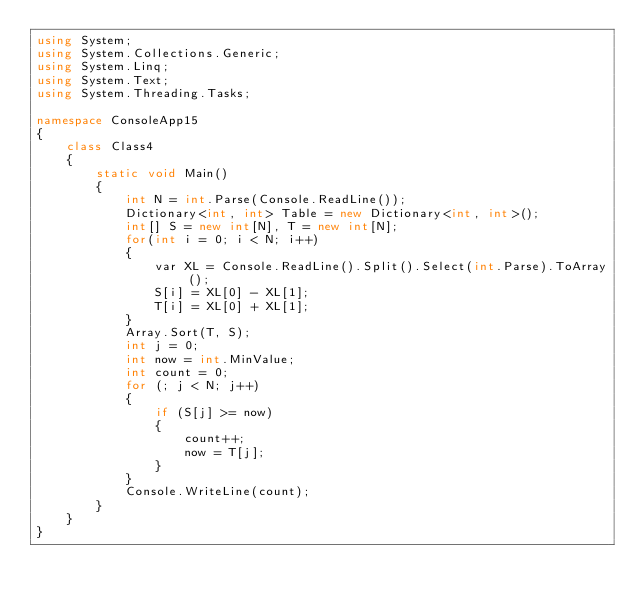Convert code to text. <code><loc_0><loc_0><loc_500><loc_500><_C#_>using System;
using System.Collections.Generic;
using System.Linq;
using System.Text;
using System.Threading.Tasks;

namespace ConsoleApp15
{
    class Class4
    {
        static void Main()
        {
            int N = int.Parse(Console.ReadLine());
            Dictionary<int, int> Table = new Dictionary<int, int>();
            int[] S = new int[N], T = new int[N];
            for(int i = 0; i < N; i++)
            {
                var XL = Console.ReadLine().Split().Select(int.Parse).ToArray();
                S[i] = XL[0] - XL[1];
                T[i] = XL[0] + XL[1];
            }
            Array.Sort(T, S);
            int j = 0;
            int now = int.MinValue;
            int count = 0;
            for (; j < N; j++)
            {
                if (S[j] >= now)
                {
                    count++;
                    now = T[j];
                }
            }
            Console.WriteLine(count);
        }
    }
}
</code> 